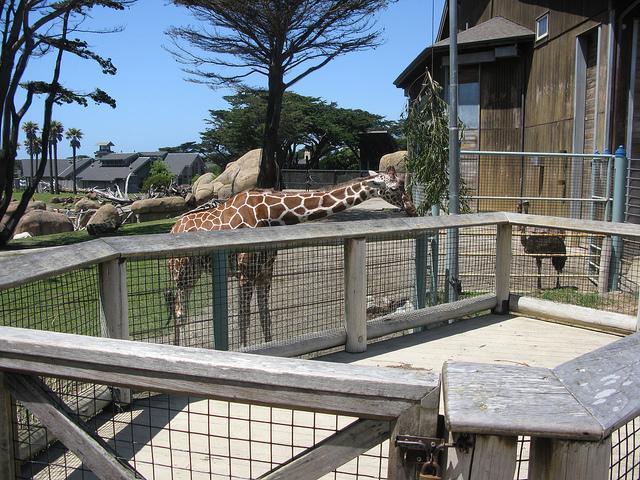How many children are near the giraffe?
Give a very brief answer. 0. 